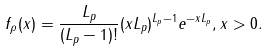<formula> <loc_0><loc_0><loc_500><loc_500>f _ { \rho } ( x ) = \frac { L _ { p } } { ( L _ { p } - 1 ) ! } ( x L _ { p } ) ^ { L _ { p } - 1 } e ^ { - x L _ { p } } , x > 0 .</formula> 